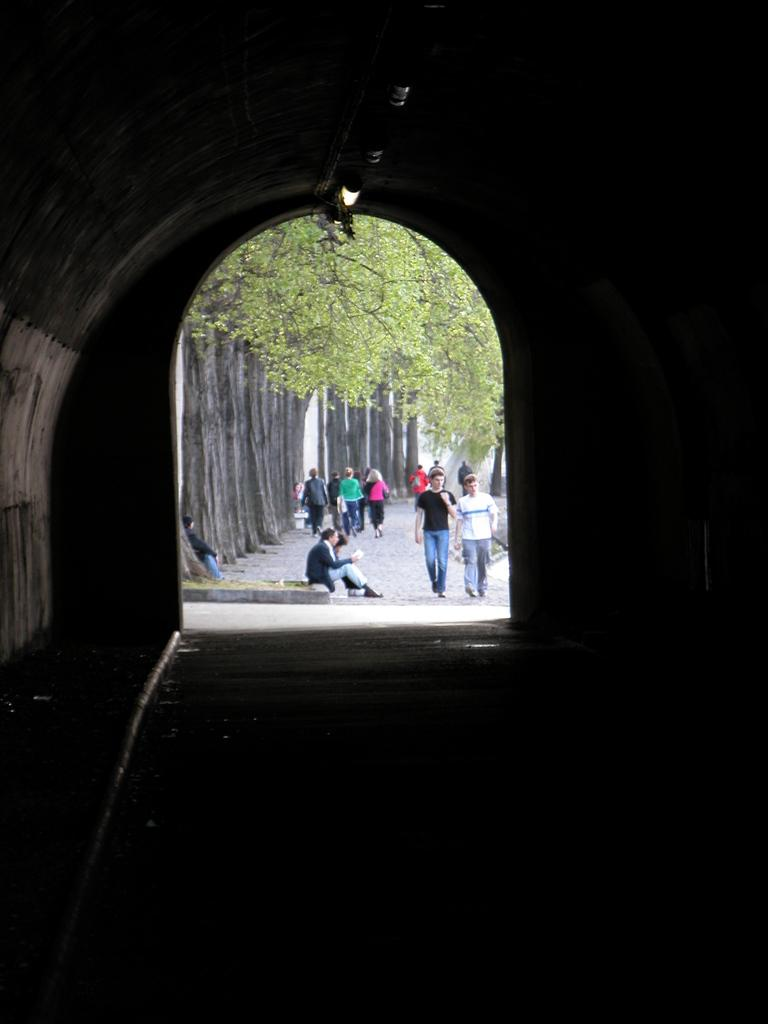What is the main subject of the image? The main subject of the image is a tunnel. What are the people in the tunnel doing? There are people walking and sitting in the tunnel. What can be seen in the background of the image? There are trees in the background of the image. What type of road can be seen leading into the tunnel in the image? There is no road visible in the image; it only shows the tunnel and the people inside it. 